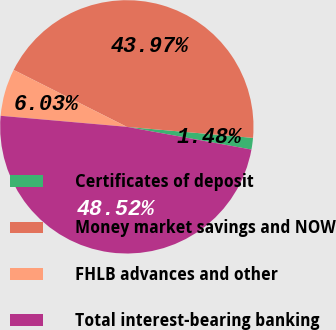Convert chart. <chart><loc_0><loc_0><loc_500><loc_500><pie_chart><fcel>Certificates of deposit<fcel>Money market savings and NOW<fcel>FHLB advances and other<fcel>Total interest-bearing banking<nl><fcel>1.48%<fcel>43.97%<fcel>6.03%<fcel>48.52%<nl></chart> 